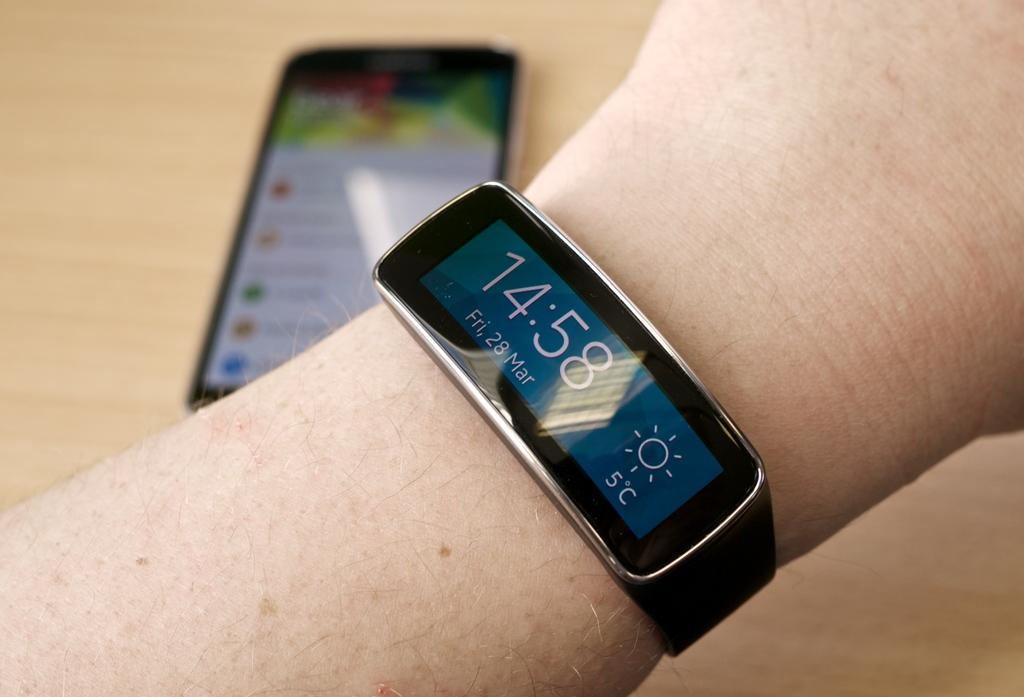<image>
Relay a brief, clear account of the picture shown. A smart watch says the time is 14:58 on the 28th of March. 